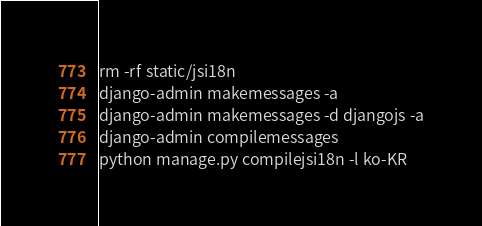Convert code to text. <code><loc_0><loc_0><loc_500><loc_500><_Bash_>rm -rf static/jsi18n
django-admin makemessages -a
django-admin makemessages -d djangojs -a
django-admin compilemessages
python manage.py compilejsi18n -l ko-KR
</code> 